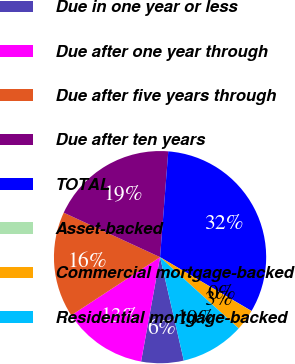<chart> <loc_0><loc_0><loc_500><loc_500><pie_chart><fcel>Due in one year or less<fcel>Due after one year through<fcel>Due after five years through<fcel>Due after ten years<fcel>TOTAL<fcel>Asset-backed<fcel>Commercial mortgage-backed<fcel>Residential mortgage-backed<nl><fcel>6.46%<fcel>12.9%<fcel>16.12%<fcel>19.35%<fcel>32.23%<fcel>0.02%<fcel>3.24%<fcel>9.68%<nl></chart> 